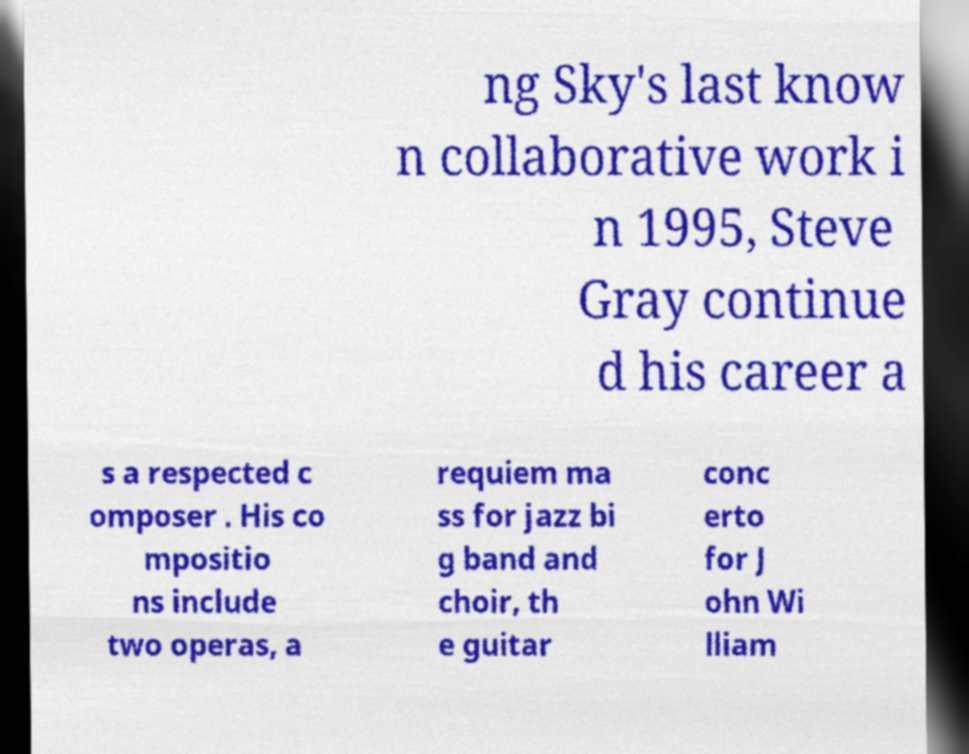Could you assist in decoding the text presented in this image and type it out clearly? ng Sky's last know n collaborative work i n 1995, Steve Gray continue d his career a s a respected c omposer . His co mpositio ns include two operas, a requiem ma ss for jazz bi g band and choir, th e guitar conc erto for J ohn Wi lliam 